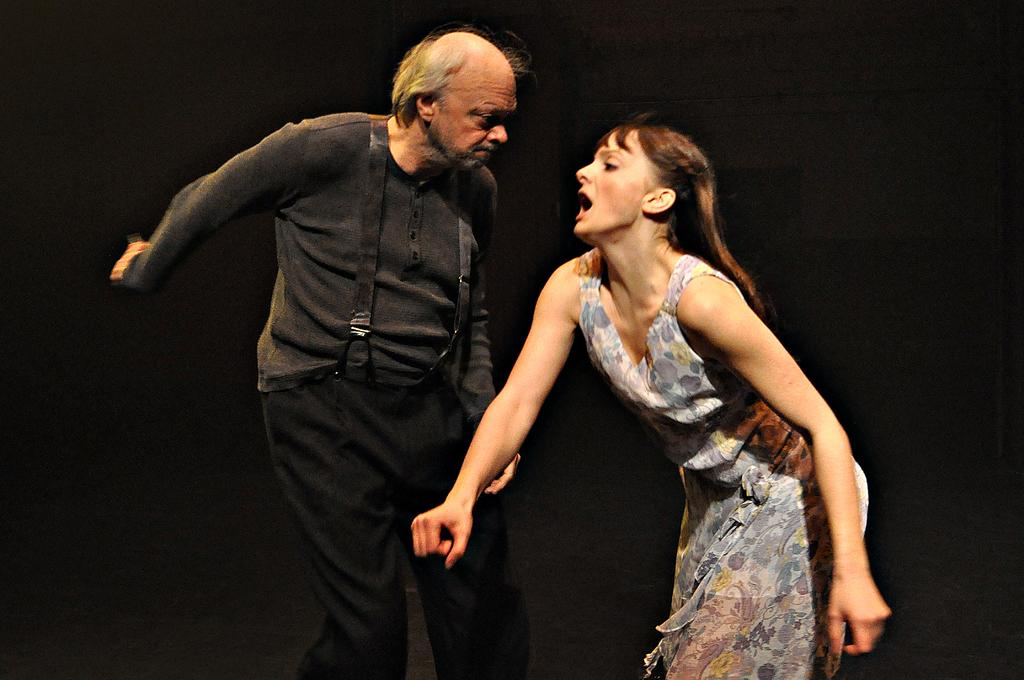What are the two people in the image doing? The man and woman in the image are standing. Can you describe the appearance of the two people? There is a man and a woman in the image, but their specific appearances are not mentioned in the facts. What is the color of the background in the image? The background of the image is dark. What type of sink can be seen in the image? There is no sink present in the image. What stage of development are the people in the image at? The facts provided do not give any information about the development stage of the people in the image. What type of credit is being discussed or shown in the image? There is no mention of credit in the image or the provided facts. 